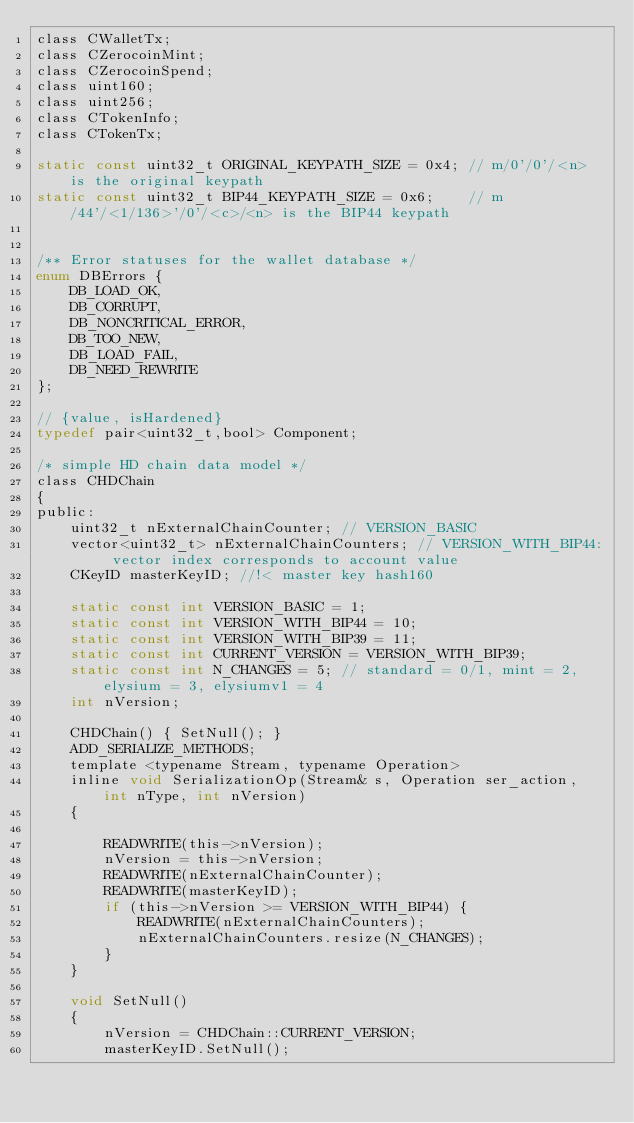<code> <loc_0><loc_0><loc_500><loc_500><_C_>class CWalletTx;
class CZerocoinMint;
class CZerocoinSpend;
class uint160;
class uint256;
class CTokenInfo;
class CTokenTx;

static const uint32_t ORIGINAL_KEYPATH_SIZE = 0x4; // m/0'/0'/<n> is the original keypath
static const uint32_t BIP44_KEYPATH_SIZE = 0x6;    // m/44'/<1/136>'/0'/<c>/<n> is the BIP44 keypath


/** Error statuses for the wallet database */
enum DBErrors {
    DB_LOAD_OK,
    DB_CORRUPT,
    DB_NONCRITICAL_ERROR,
    DB_TOO_NEW,
    DB_LOAD_FAIL,
    DB_NEED_REWRITE
};

// {value, isHardened}
typedef pair<uint32_t,bool> Component;

/* simple HD chain data model */
class CHDChain
{
public:
    uint32_t nExternalChainCounter; // VERSION_BASIC
    vector<uint32_t> nExternalChainCounters; // VERSION_WITH_BIP44: vector index corresponds to account value
    CKeyID masterKeyID; //!< master key hash160

    static const int VERSION_BASIC = 1;
    static const int VERSION_WITH_BIP44 = 10;
    static const int VERSION_WITH_BIP39 = 11;
    static const int CURRENT_VERSION = VERSION_WITH_BIP39;
    static const int N_CHANGES = 5; // standard = 0/1, mint = 2, elysium = 3, elysiumv1 = 4
    int nVersion;

    CHDChain() { SetNull(); }
    ADD_SERIALIZE_METHODS;
    template <typename Stream, typename Operation>
    inline void SerializationOp(Stream& s, Operation ser_action, int nType, int nVersion)
    {

        READWRITE(this->nVersion);
        nVersion = this->nVersion;
        READWRITE(nExternalChainCounter);
        READWRITE(masterKeyID);
        if (this->nVersion >= VERSION_WITH_BIP44) {
            READWRITE(nExternalChainCounters);
            nExternalChainCounters.resize(N_CHANGES);
        }
    }

    void SetNull()
    {
        nVersion = CHDChain::CURRENT_VERSION;
        masterKeyID.SetNull();</code> 